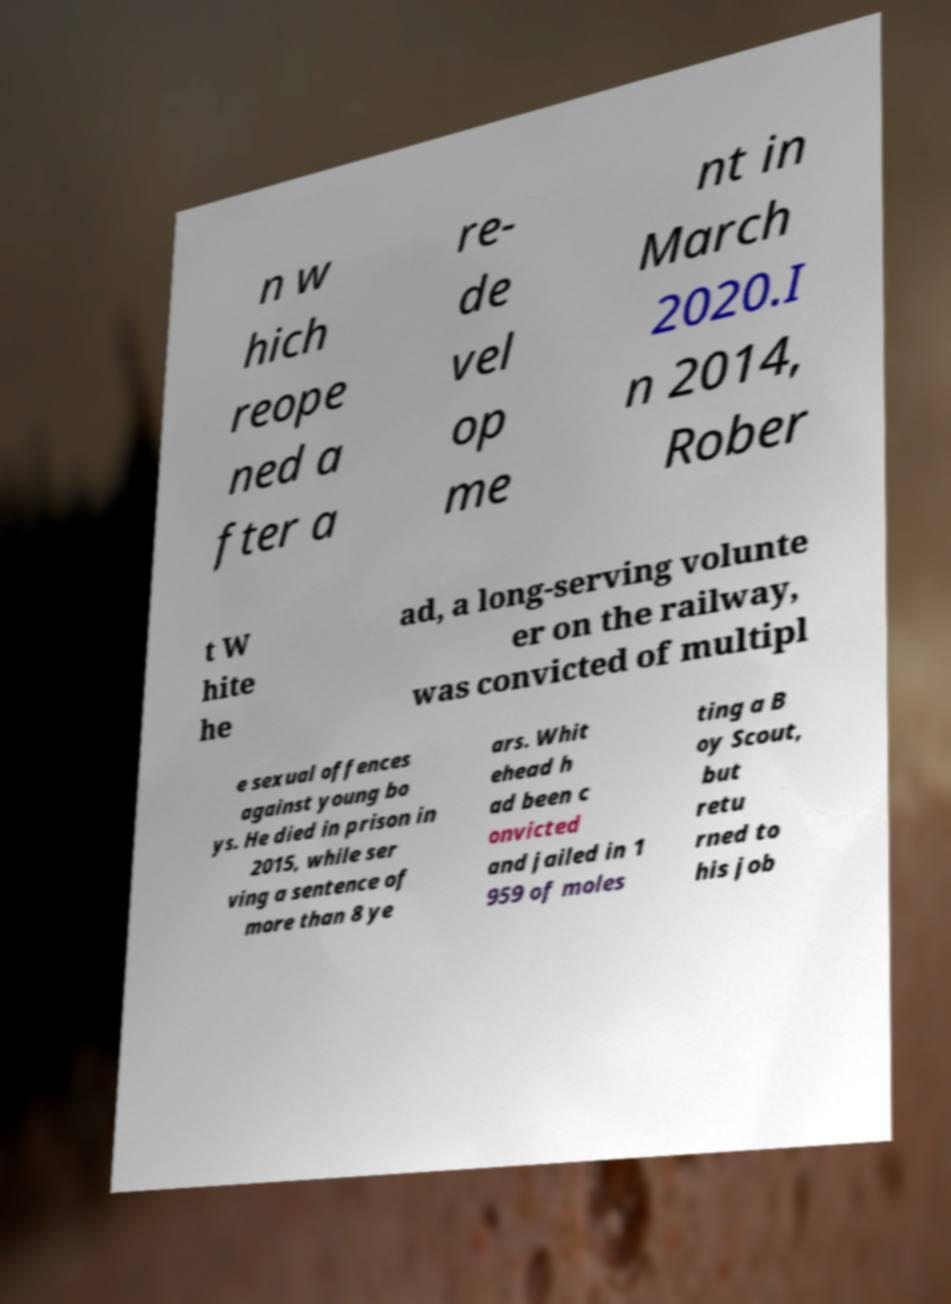There's text embedded in this image that I need extracted. Can you transcribe it verbatim? n w hich reope ned a fter a re- de vel op me nt in March 2020.I n 2014, Rober t W hite he ad, a long-serving volunte er on the railway, was convicted of multipl e sexual offences against young bo ys. He died in prison in 2015, while ser ving a sentence of more than 8 ye ars. Whit ehead h ad been c onvicted and jailed in 1 959 of moles ting a B oy Scout, but retu rned to his job 